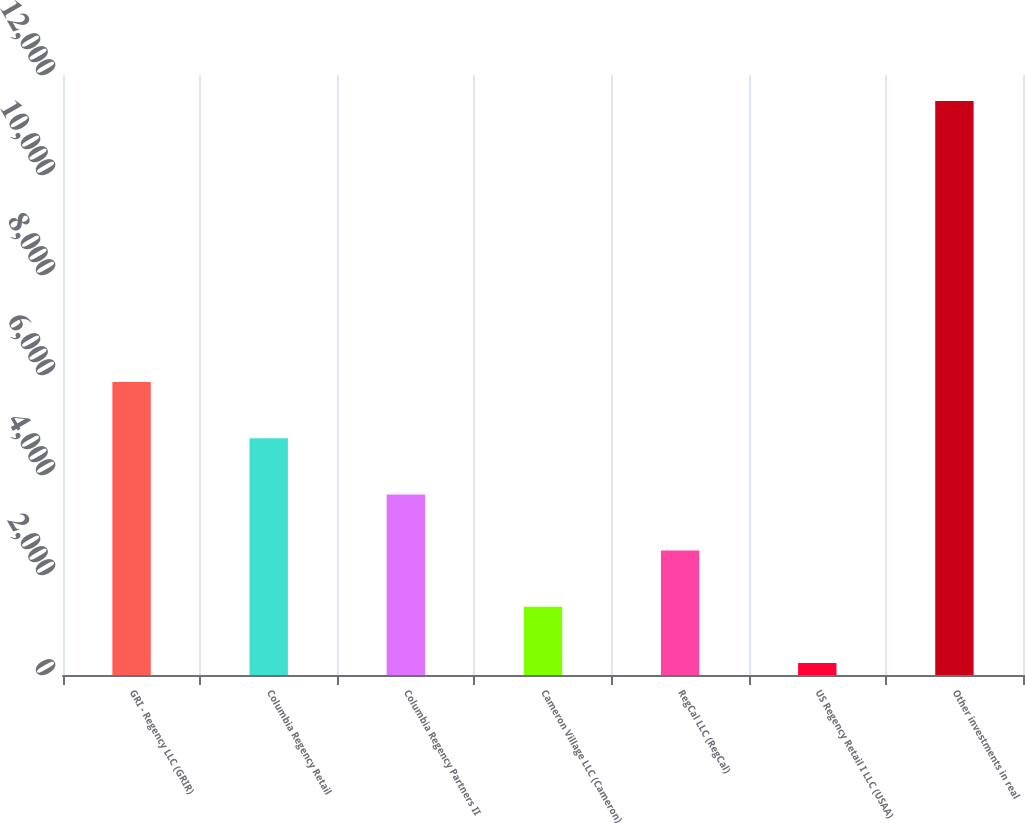Convert chart to OTSL. <chart><loc_0><loc_0><loc_500><loc_500><bar_chart><fcel>GRI - Regency LLC (GRIR)<fcel>Columbia Regency Retail<fcel>Columbia Regency Partners II<fcel>Cameron Village LLC (Cameron)<fcel>RegCal LLC (RegCal)<fcel>US Regency Retail I LLC (USAA)<fcel>Other investments in real<nl><fcel>5860.5<fcel>4736.4<fcel>3612.3<fcel>1364.1<fcel>2488.2<fcel>240<fcel>11481<nl></chart> 